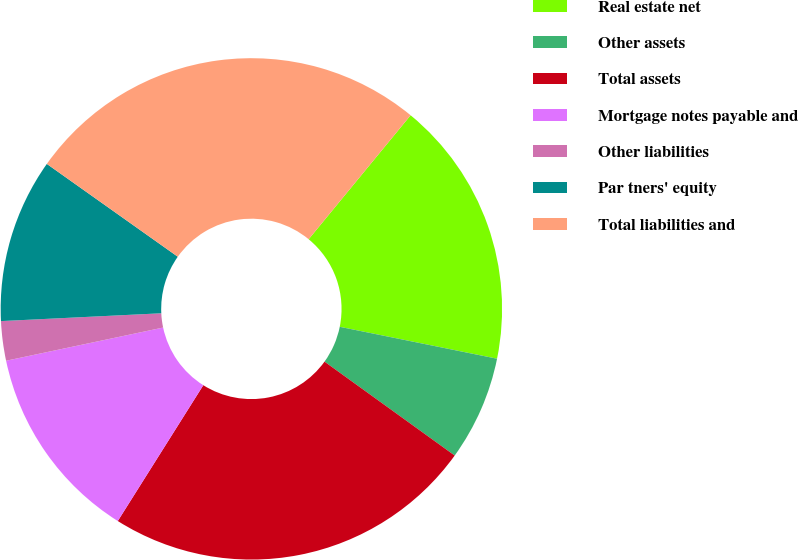Convert chart. <chart><loc_0><loc_0><loc_500><loc_500><pie_chart><fcel>Real estate net<fcel>Other assets<fcel>Total assets<fcel>Mortgage notes payable and<fcel>Other liabilities<fcel>Par tners' equity<fcel>Total liabilities and<nl><fcel>17.23%<fcel>6.76%<fcel>24.0%<fcel>12.74%<fcel>2.54%<fcel>10.59%<fcel>26.14%<nl></chart> 